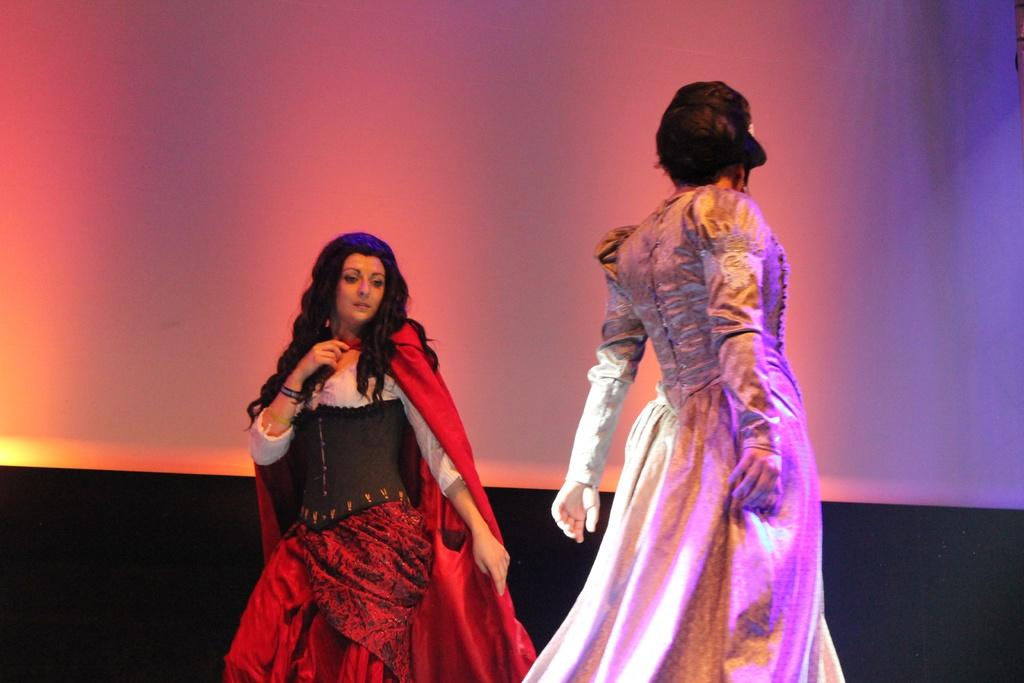How many people are in the image? There are two women in the image. What are the women wearing? The women are wearing costumes. What can be seen in the background of the image? There is a white color curtain in the background of the image. What is the taste of the suit in the image? There is no suit present in the image, and therefore no taste can be associated with it. 